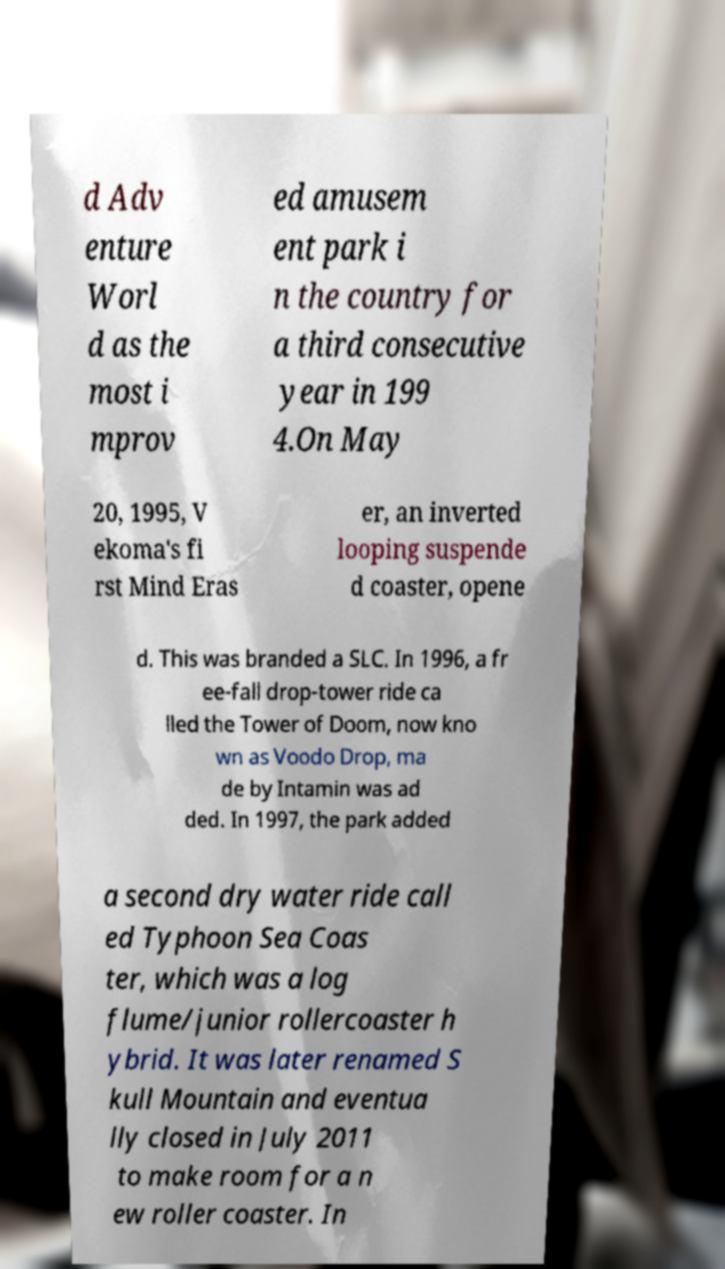Can you read and provide the text displayed in the image?This photo seems to have some interesting text. Can you extract and type it out for me? d Adv enture Worl d as the most i mprov ed amusem ent park i n the country for a third consecutive year in 199 4.On May 20, 1995, V ekoma's fi rst Mind Eras er, an inverted looping suspende d coaster, opene d. This was branded a SLC. In 1996, a fr ee-fall drop-tower ride ca lled the Tower of Doom, now kno wn as Voodo Drop, ma de by Intamin was ad ded. In 1997, the park added a second dry water ride call ed Typhoon Sea Coas ter, which was a log flume/junior rollercoaster h ybrid. It was later renamed S kull Mountain and eventua lly closed in July 2011 to make room for a n ew roller coaster. In 